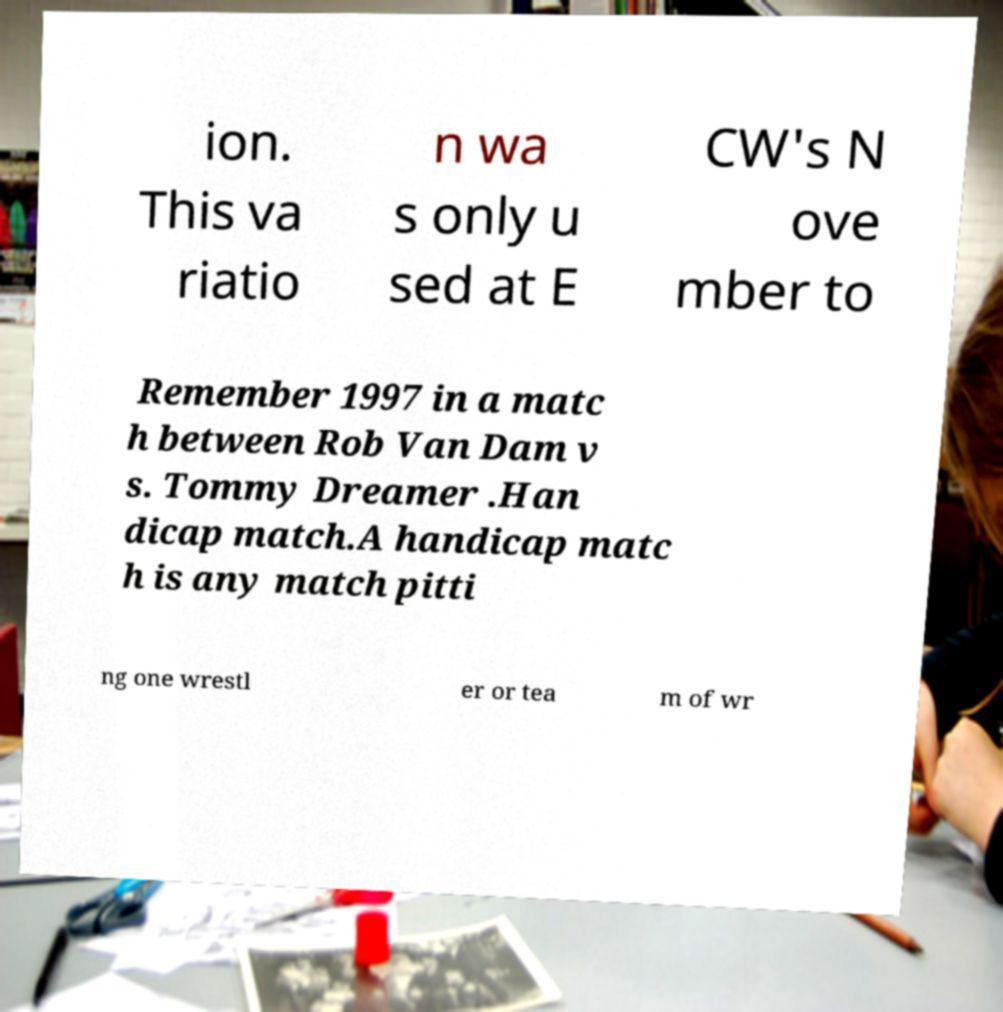Please read and relay the text visible in this image. What does it say? ion. This va riatio n wa s only u sed at E CW's N ove mber to Remember 1997 in a matc h between Rob Van Dam v s. Tommy Dreamer .Han dicap match.A handicap matc h is any match pitti ng one wrestl er or tea m of wr 